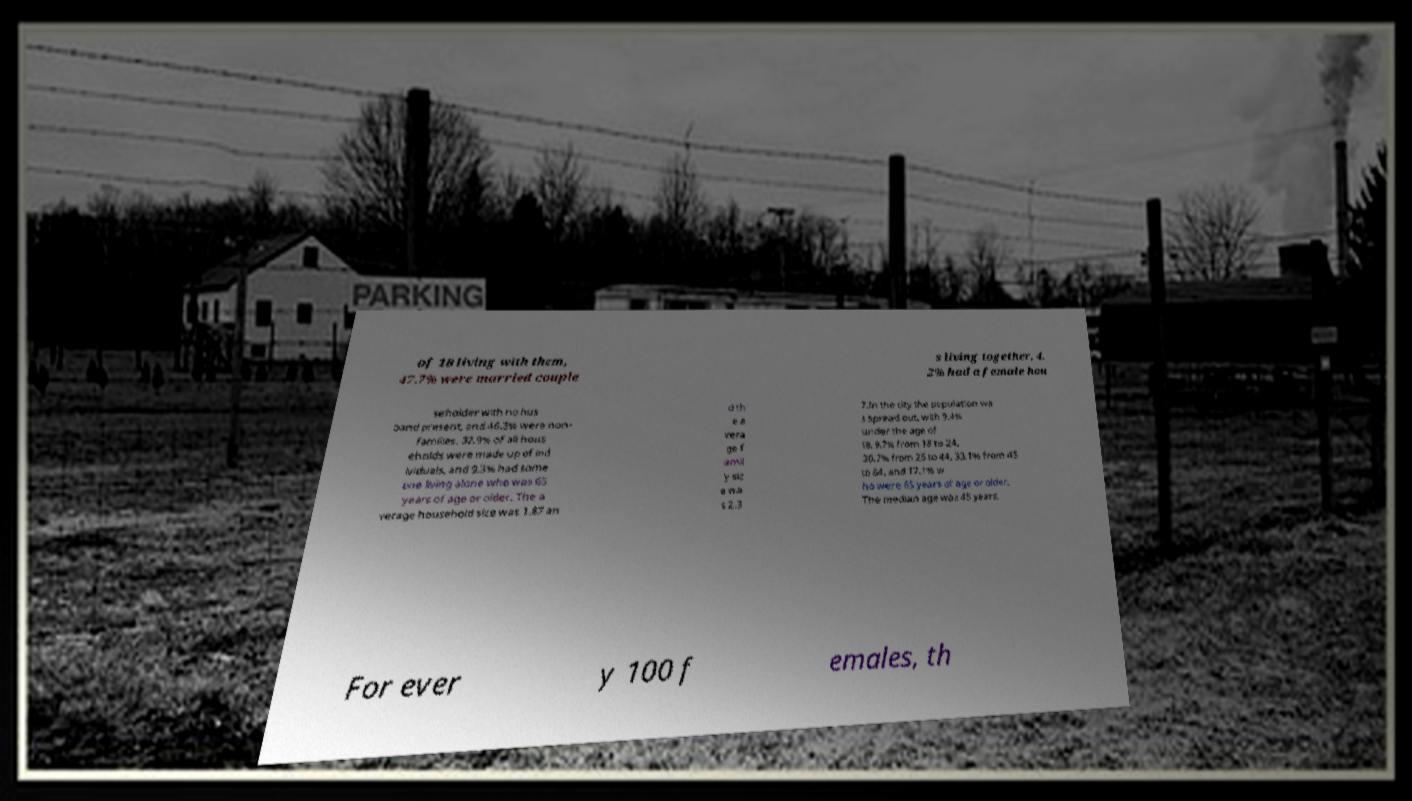There's text embedded in this image that I need extracted. Can you transcribe it verbatim? of 18 living with them, 47.7% were married couple s living together, 4. 2% had a female hou seholder with no hus band present, and 46.3% were non- families. 37.9% of all hous eholds were made up of ind ividuals, and 9.3% had some one living alone who was 65 years of age or older. The a verage household size was 1.87 an d th e a vera ge f amil y siz e wa s 2.3 7.In the city the population wa s spread out, with 9.4% under the age of 18, 9.7% from 18 to 24, 30.7% from 25 to 44, 33.1% from 45 to 64, and 17.1% w ho were 65 years of age or older. The median age was 45 years. For ever y 100 f emales, th 